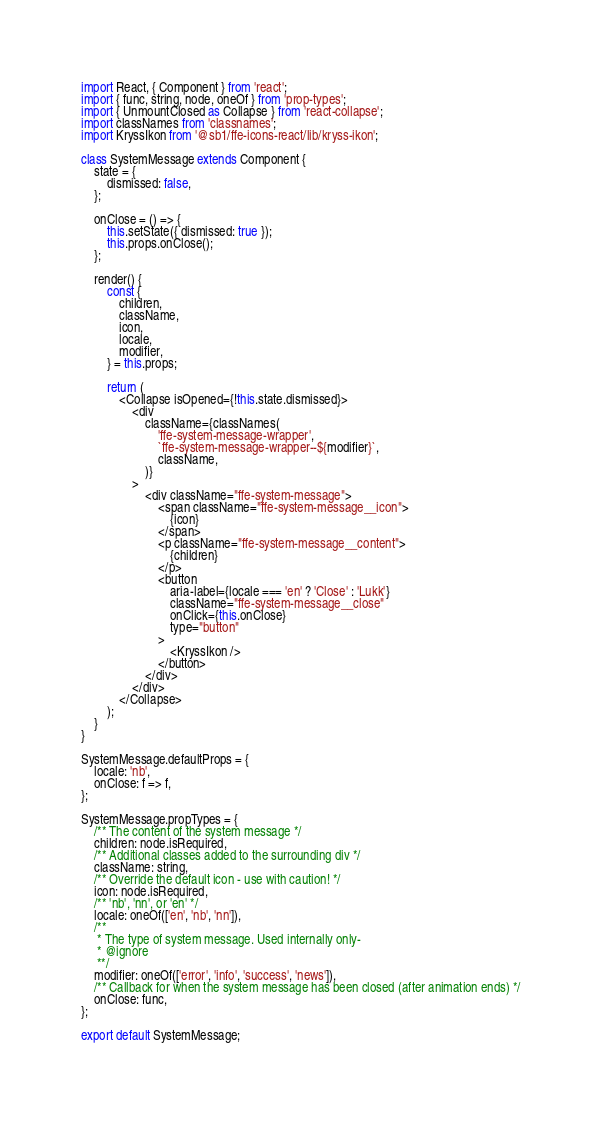<code> <loc_0><loc_0><loc_500><loc_500><_JavaScript_>import React, { Component } from 'react';
import { func, string, node, oneOf } from 'prop-types';
import { UnmountClosed as Collapse } from 'react-collapse';
import classNames from 'classnames';
import KryssIkon from '@sb1/ffe-icons-react/lib/kryss-ikon';

class SystemMessage extends Component {
    state = {
        dismissed: false,
    };

    onClose = () => {
        this.setState({ dismissed: true });
        this.props.onClose();
    };

    render() {
        const {
            children,
            className,
            icon,
            locale,
            modifier,
        } = this.props;

        return (
            <Collapse isOpened={!this.state.dismissed}>
                <div
                    className={classNames(
                        'ffe-system-message-wrapper',
                        `ffe-system-message-wrapper--${modifier}`,
                        className,
                    )}
                >
                    <div className="ffe-system-message">
                        <span className="ffe-system-message__icon">
                            {icon}
                        </span>
                        <p className="ffe-system-message__content">
                            {children}
                        </p>
                        <button
                            aria-label={locale === 'en' ? 'Close' : 'Lukk'}
                            className="ffe-system-message__close"
                            onClick={this.onClose}
                            type="button"
                        >
                            <KryssIkon />
                        </button>
                    </div>
                </div>
            </Collapse>
        );
    }
}

SystemMessage.defaultProps = {
    locale: 'nb',
    onClose: f => f,
};

SystemMessage.propTypes = {
    /** The content of the system message */
    children: node.isRequired,
    /** Additional classes added to the surrounding div */
    className: string,
    /** Override the default icon - use with caution! */
    icon: node.isRequired,
    /** 'nb', 'nn', or 'en' */
    locale: oneOf(['en', 'nb', 'nn']),
    /**
     * The type of system message. Used internally only-
     * @ignore
     **/
    modifier: oneOf(['error', 'info', 'success', 'news']),
    /** Callback for when the system message has been closed (after animation ends) */
    onClose: func,
};

export default SystemMessage;
</code> 